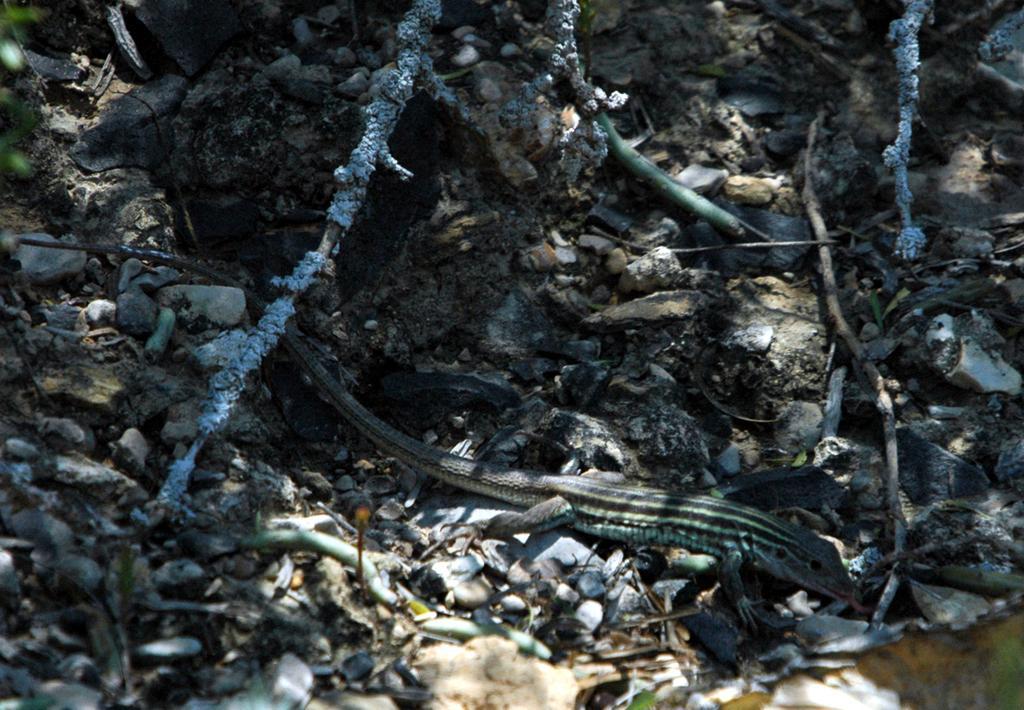In one or two sentences, can you explain what this image depicts? In the image there is a reptile crawling on the ground, there are many stones and some dry items were present around the reptile. 